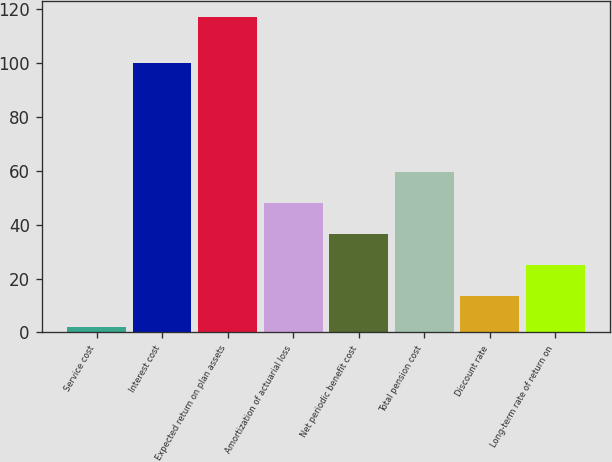Convert chart to OTSL. <chart><loc_0><loc_0><loc_500><loc_500><bar_chart><fcel>Service cost<fcel>Interest cost<fcel>Expected return on plan assets<fcel>Amortization of actuarial loss<fcel>Net periodic benefit cost<fcel>Total pension cost<fcel>Discount rate<fcel>Long-term rate of return on<nl><fcel>2<fcel>100<fcel>117<fcel>48<fcel>36.5<fcel>59.5<fcel>13.5<fcel>25<nl></chart> 